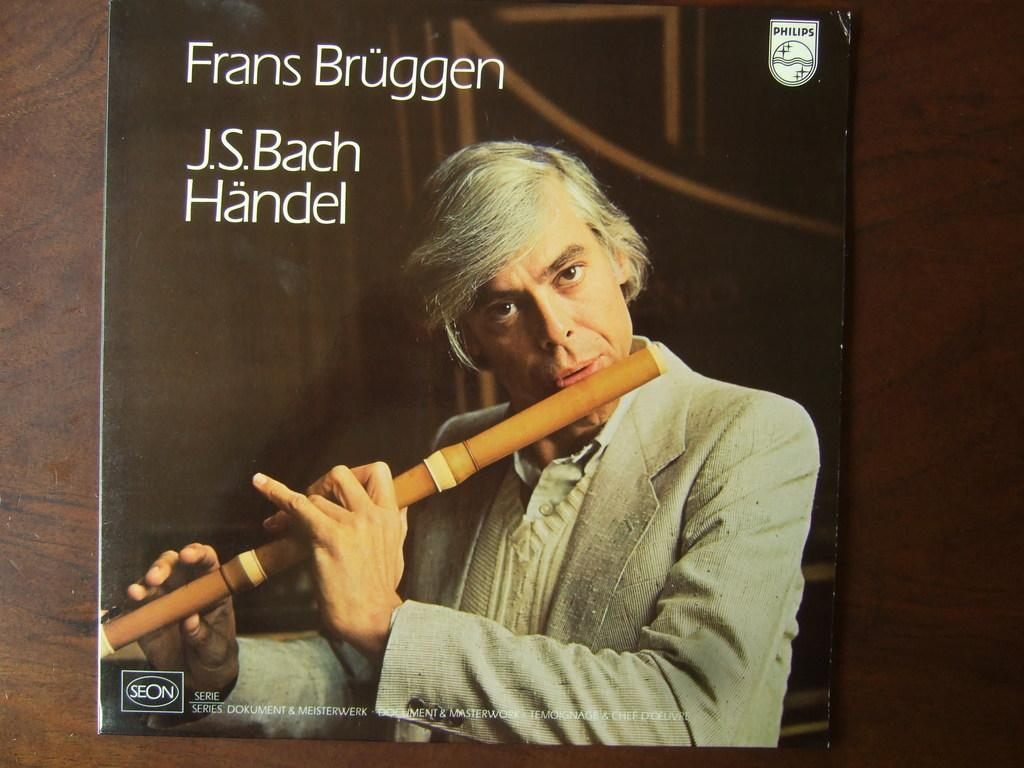What is depicted on the poster in the image? The poster features a man playing a flute. What can be seen in the background of the image? There is a wall in the background of the image. Is there any text on the poster? Yes, there is text on the poster. What type of grain is being served with a fork on the poster? There is no grain or fork present on the poster; it features a man playing a flute. What team is the man playing the flute for in the image? There is no indication of a team in the image; it simply shows a man playing a flute. 